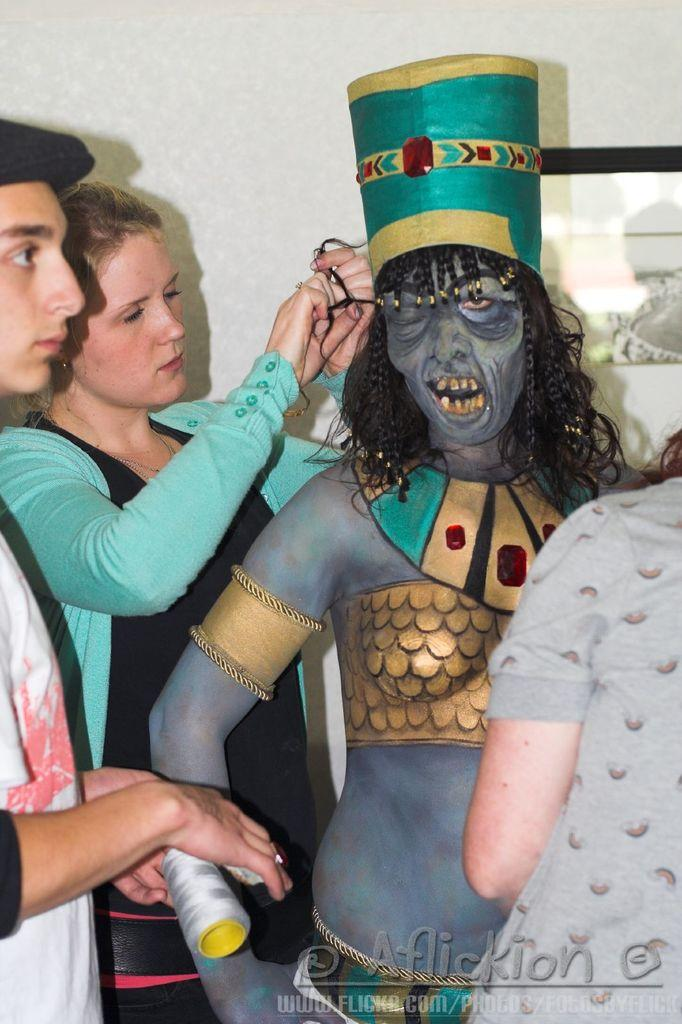How many people are in the image? There is a group of people in the image. What are the people doing in the image? The people are on a path. Can you describe the attire of one of the people in the image? There is a person in fancy dress. What is behind the people in the image? There is a wall behind the people. Is there any additional information about the image itself? The image has a watermark. Can you tell me how many times the grandmother untied the knot in the image? There is no grandmother or knot present in the image. What type of frog can be seen sitting on the wall in the image? There is no frog present in the image; only a group of people, a path, a person in fancy dress, a wall, and a watermark are visible. 